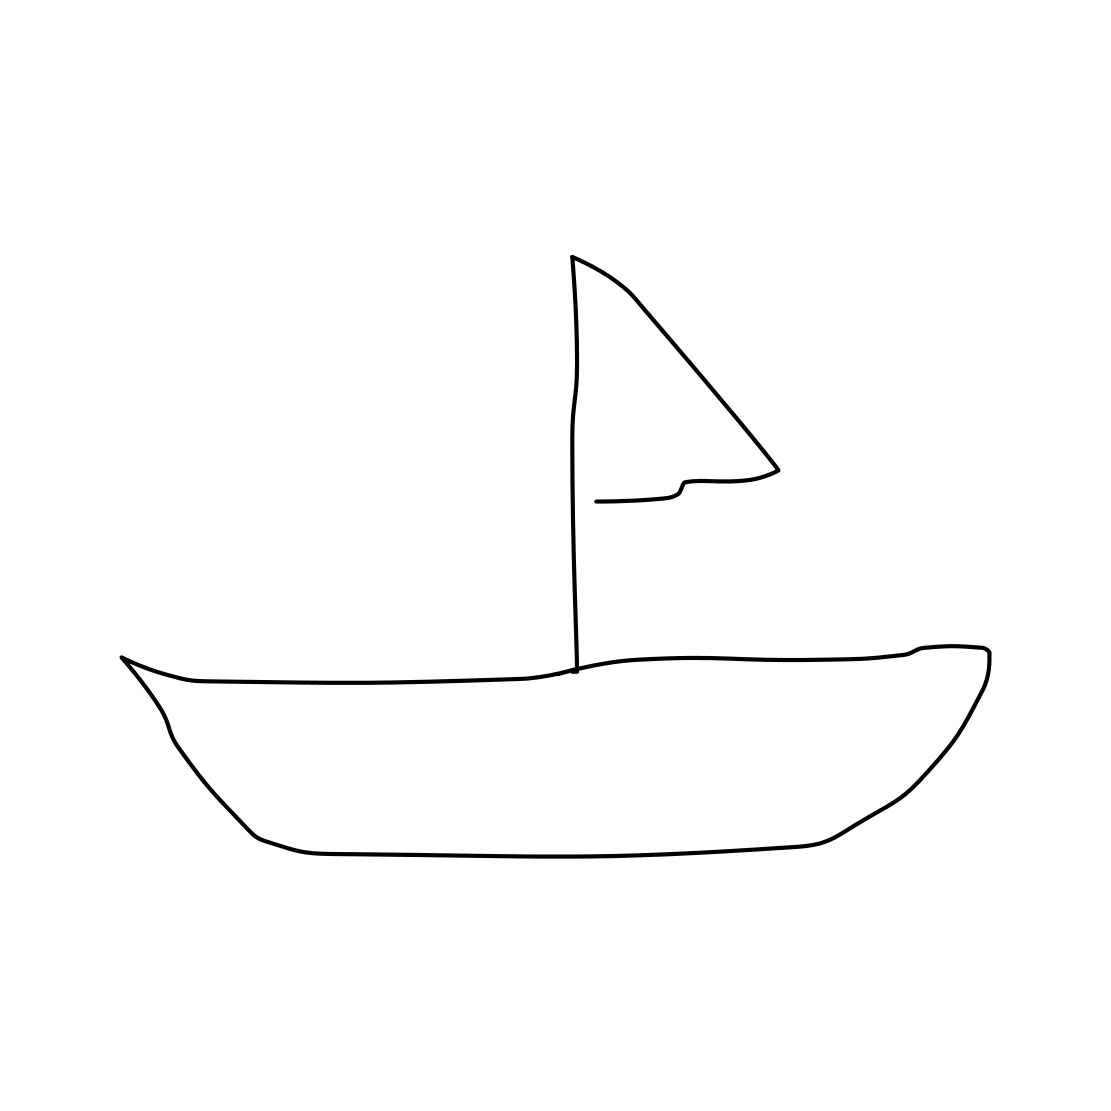Could you tell me more about this style of art? Certainly! The image features a very minimalistic and modern style, commonly found in line art. It's characterized by its simplicity and focus on form and silhouette, using clean lines to convey the essence of the subject without detail. 